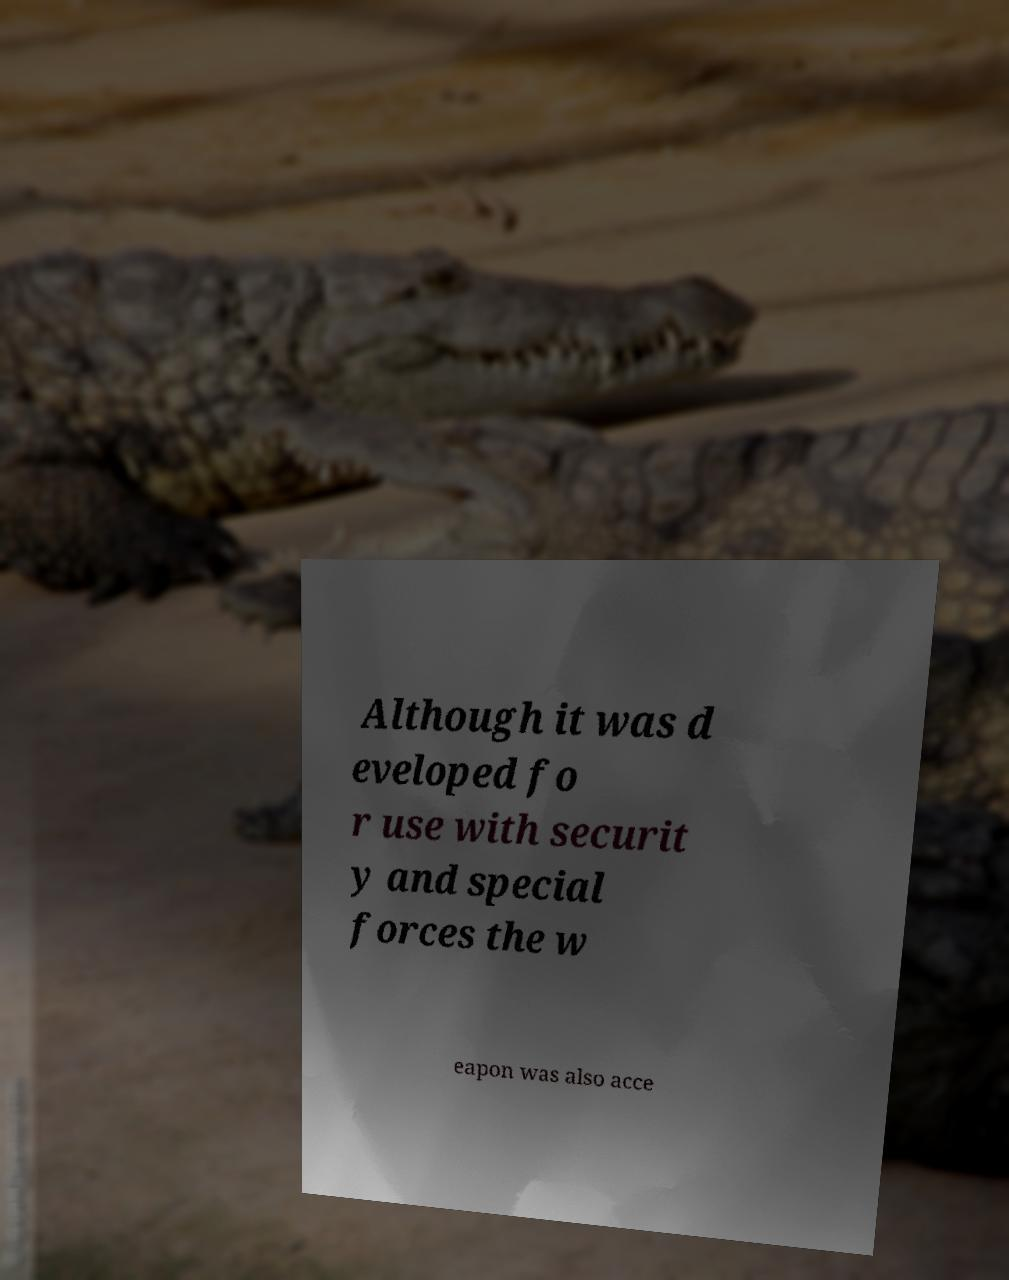What messages or text are displayed in this image? I need them in a readable, typed format. Although it was d eveloped fo r use with securit y and special forces the w eapon was also acce 